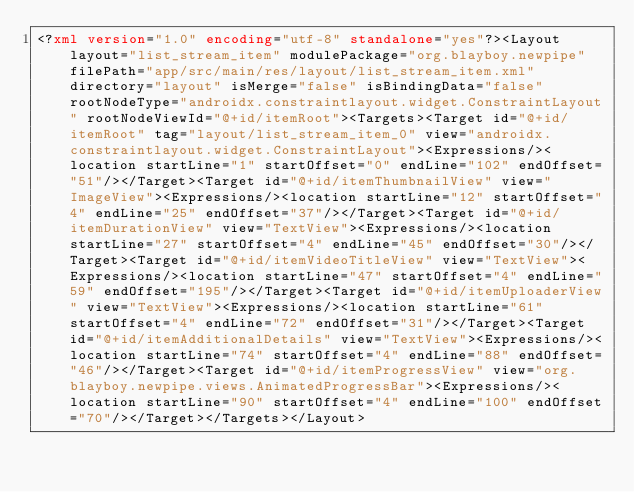<code> <loc_0><loc_0><loc_500><loc_500><_XML_><?xml version="1.0" encoding="utf-8" standalone="yes"?><Layout layout="list_stream_item" modulePackage="org.blayboy.newpipe" filePath="app/src/main/res/layout/list_stream_item.xml" directory="layout" isMerge="false" isBindingData="false" rootNodeType="androidx.constraintlayout.widget.ConstraintLayout" rootNodeViewId="@+id/itemRoot"><Targets><Target id="@+id/itemRoot" tag="layout/list_stream_item_0" view="androidx.constraintlayout.widget.ConstraintLayout"><Expressions/><location startLine="1" startOffset="0" endLine="102" endOffset="51"/></Target><Target id="@+id/itemThumbnailView" view="ImageView"><Expressions/><location startLine="12" startOffset="4" endLine="25" endOffset="37"/></Target><Target id="@+id/itemDurationView" view="TextView"><Expressions/><location startLine="27" startOffset="4" endLine="45" endOffset="30"/></Target><Target id="@+id/itemVideoTitleView" view="TextView"><Expressions/><location startLine="47" startOffset="4" endLine="59" endOffset="195"/></Target><Target id="@+id/itemUploaderView" view="TextView"><Expressions/><location startLine="61" startOffset="4" endLine="72" endOffset="31"/></Target><Target id="@+id/itemAdditionalDetails" view="TextView"><Expressions/><location startLine="74" startOffset="4" endLine="88" endOffset="46"/></Target><Target id="@+id/itemProgressView" view="org.blayboy.newpipe.views.AnimatedProgressBar"><Expressions/><location startLine="90" startOffset="4" endLine="100" endOffset="70"/></Target></Targets></Layout></code> 